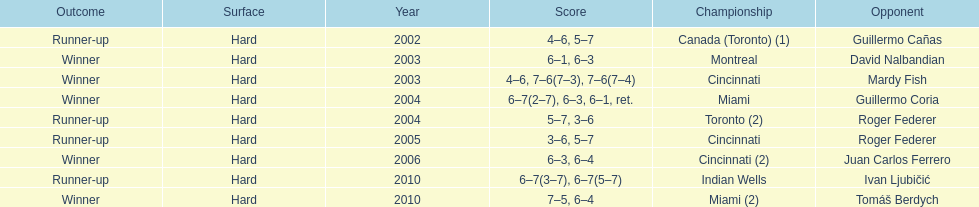How many times was roger federer a runner-up? 2. 